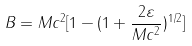Convert formula to latex. <formula><loc_0><loc_0><loc_500><loc_500>B = M c ^ { 2 } [ 1 - ( 1 + \frac { 2 \varepsilon } { M c ^ { 2 } } ) ^ { 1 / 2 } ]</formula> 